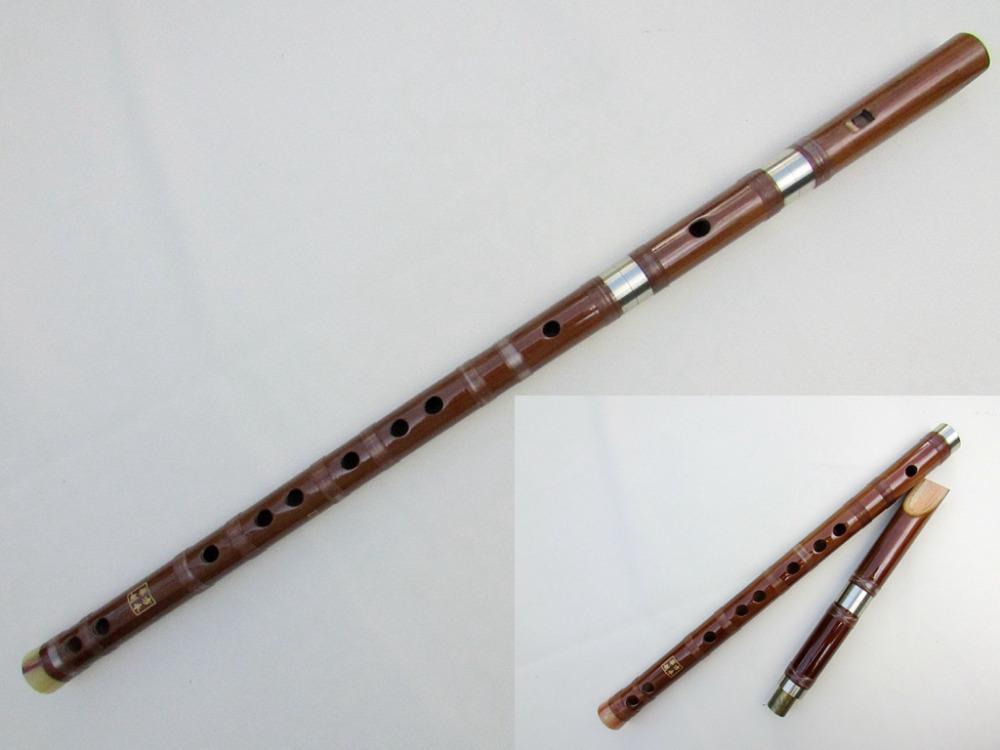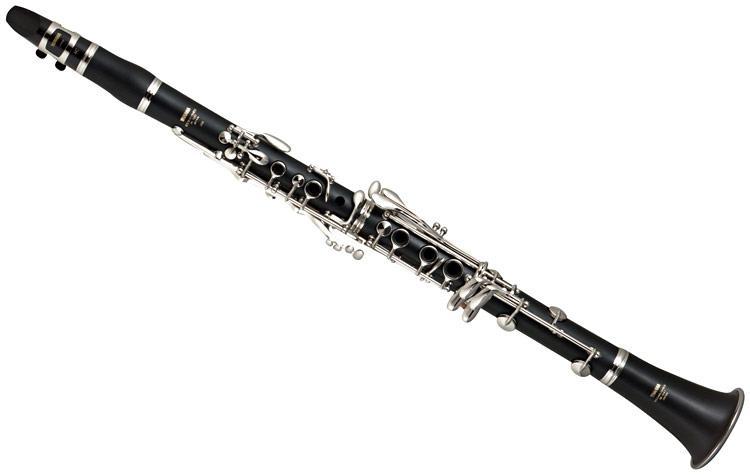The first image is the image on the left, the second image is the image on the right. Evaluate the accuracy of this statement regarding the images: "The combined images contain one straight black flute with a flared end, one complete wooden flute, and two flute pieces displayed with one end close together.". Is it true? Answer yes or no. Yes. 